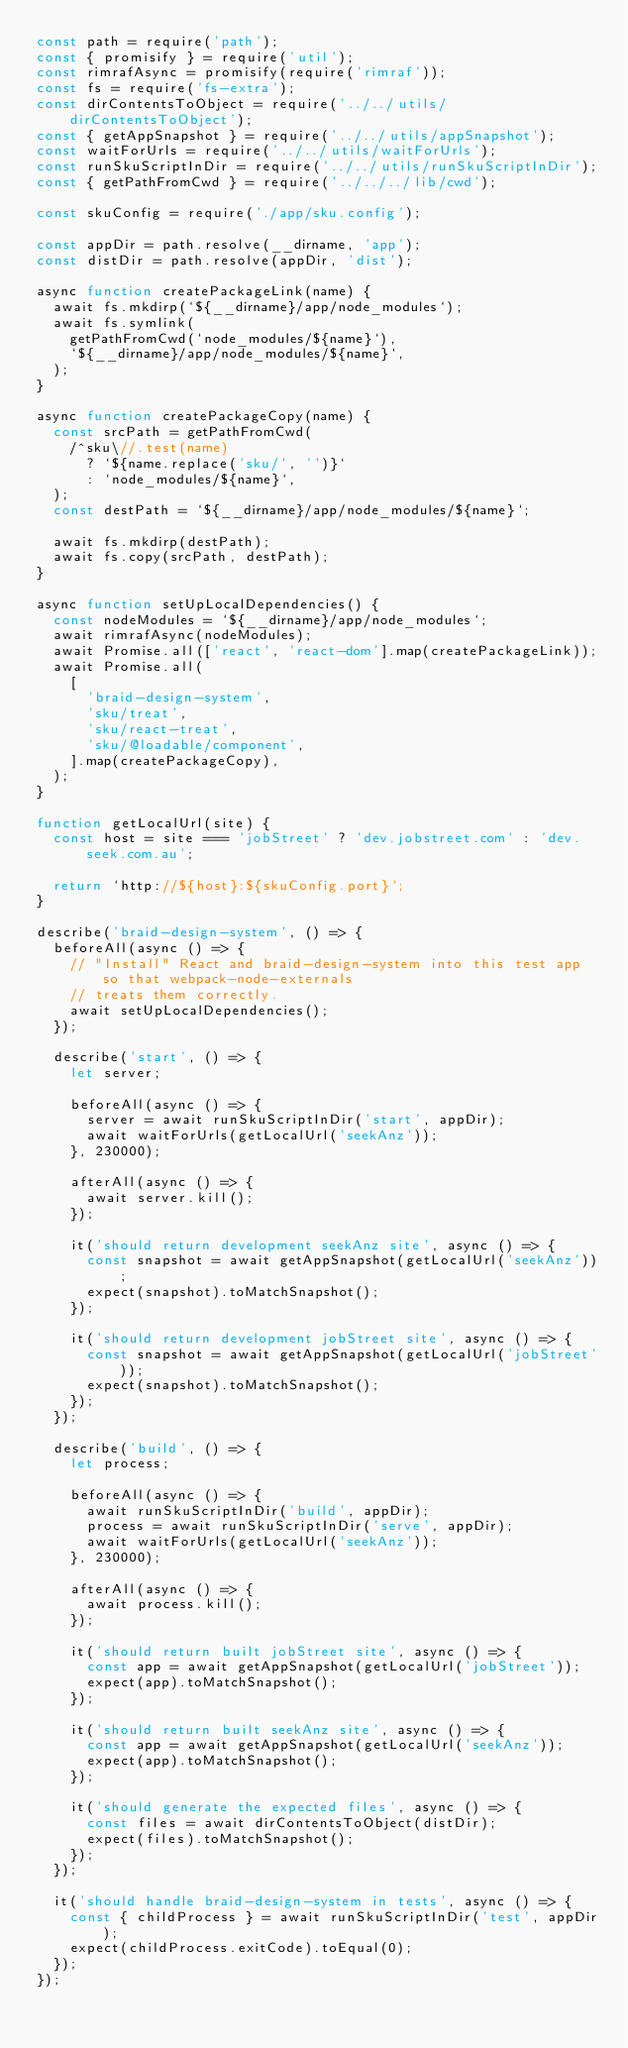Convert code to text. <code><loc_0><loc_0><loc_500><loc_500><_JavaScript_>const path = require('path');
const { promisify } = require('util');
const rimrafAsync = promisify(require('rimraf'));
const fs = require('fs-extra');
const dirContentsToObject = require('../../utils/dirContentsToObject');
const { getAppSnapshot } = require('../../utils/appSnapshot');
const waitForUrls = require('../../utils/waitForUrls');
const runSkuScriptInDir = require('../../utils/runSkuScriptInDir');
const { getPathFromCwd } = require('../../../lib/cwd');

const skuConfig = require('./app/sku.config');

const appDir = path.resolve(__dirname, 'app');
const distDir = path.resolve(appDir, 'dist');

async function createPackageLink(name) {
  await fs.mkdirp(`${__dirname}/app/node_modules`);
  await fs.symlink(
    getPathFromCwd(`node_modules/${name}`),
    `${__dirname}/app/node_modules/${name}`,
  );
}

async function createPackageCopy(name) {
  const srcPath = getPathFromCwd(
    /^sku\//.test(name)
      ? `${name.replace('sku/', '')}`
      : `node_modules/${name}`,
  );
  const destPath = `${__dirname}/app/node_modules/${name}`;

  await fs.mkdirp(destPath);
  await fs.copy(srcPath, destPath);
}

async function setUpLocalDependencies() {
  const nodeModules = `${__dirname}/app/node_modules`;
  await rimrafAsync(nodeModules);
  await Promise.all(['react', 'react-dom'].map(createPackageLink));
  await Promise.all(
    [
      'braid-design-system',
      'sku/treat',
      'sku/react-treat',
      'sku/@loadable/component',
    ].map(createPackageCopy),
  );
}

function getLocalUrl(site) {
  const host = site === 'jobStreet' ? 'dev.jobstreet.com' : 'dev.seek.com.au';

  return `http://${host}:${skuConfig.port}`;
}

describe('braid-design-system', () => {
  beforeAll(async () => {
    // "Install" React and braid-design-system into this test app so that webpack-node-externals
    // treats them correctly.
    await setUpLocalDependencies();
  });

  describe('start', () => {
    let server;

    beforeAll(async () => {
      server = await runSkuScriptInDir('start', appDir);
      await waitForUrls(getLocalUrl('seekAnz'));
    }, 230000);

    afterAll(async () => {
      await server.kill();
    });

    it('should return development seekAnz site', async () => {
      const snapshot = await getAppSnapshot(getLocalUrl('seekAnz'));
      expect(snapshot).toMatchSnapshot();
    });

    it('should return development jobStreet site', async () => {
      const snapshot = await getAppSnapshot(getLocalUrl('jobStreet'));
      expect(snapshot).toMatchSnapshot();
    });
  });

  describe('build', () => {
    let process;

    beforeAll(async () => {
      await runSkuScriptInDir('build', appDir);
      process = await runSkuScriptInDir('serve', appDir);
      await waitForUrls(getLocalUrl('seekAnz'));
    }, 230000);

    afterAll(async () => {
      await process.kill();
    });

    it('should return built jobStreet site', async () => {
      const app = await getAppSnapshot(getLocalUrl('jobStreet'));
      expect(app).toMatchSnapshot();
    });

    it('should return built seekAnz site', async () => {
      const app = await getAppSnapshot(getLocalUrl('seekAnz'));
      expect(app).toMatchSnapshot();
    });

    it('should generate the expected files', async () => {
      const files = await dirContentsToObject(distDir);
      expect(files).toMatchSnapshot();
    });
  });

  it('should handle braid-design-system in tests', async () => {
    const { childProcess } = await runSkuScriptInDir('test', appDir);
    expect(childProcess.exitCode).toEqual(0);
  });
});
</code> 